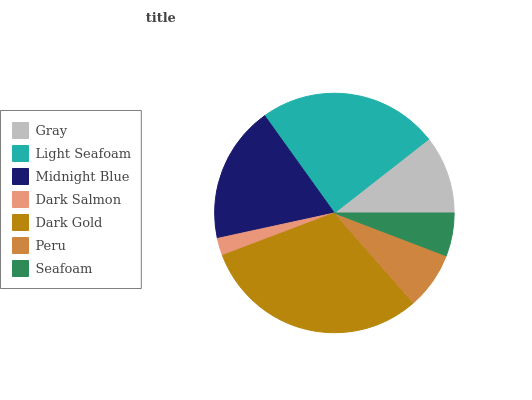Is Dark Salmon the minimum?
Answer yes or no. Yes. Is Dark Gold the maximum?
Answer yes or no. Yes. Is Light Seafoam the minimum?
Answer yes or no. No. Is Light Seafoam the maximum?
Answer yes or no. No. Is Light Seafoam greater than Gray?
Answer yes or no. Yes. Is Gray less than Light Seafoam?
Answer yes or no. Yes. Is Gray greater than Light Seafoam?
Answer yes or no. No. Is Light Seafoam less than Gray?
Answer yes or no. No. Is Gray the high median?
Answer yes or no. Yes. Is Gray the low median?
Answer yes or no. Yes. Is Dark Salmon the high median?
Answer yes or no. No. Is Dark Gold the low median?
Answer yes or no. No. 